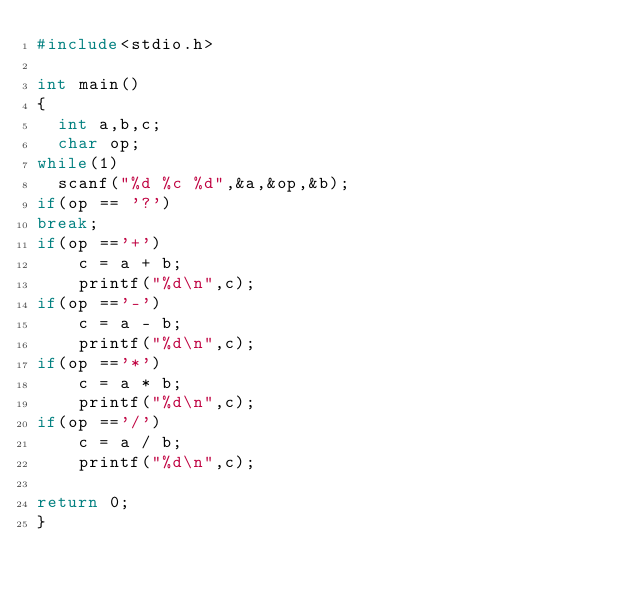Convert code to text. <code><loc_0><loc_0><loc_500><loc_500><_C_>#include<stdio.h>
 
int main()
{
  int a,b,c;
  char op;
while(1)
  scanf("%d %c %d",&a,&op,&b); 
if(op == '?')
break;  
if(op =='+')
    c = a + b;
    printf("%d\n",c);
if(op =='-')
    c = a - b;
    printf("%d\n",c);
if(op =='*')
    c = a * b;
    printf("%d\n",c);
if(op =='/')
    c = a / b;
    printf("%d\n",c);
     
return 0;
}
</code> 